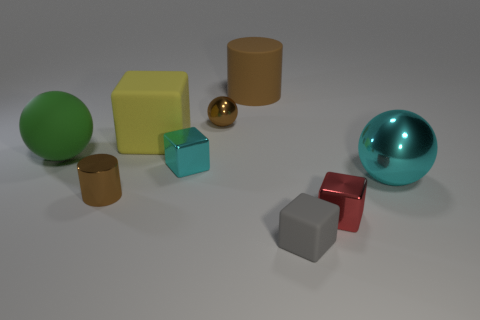There is a matte thing that is the same shape as the big metal thing; what is its size?
Ensure brevity in your answer.  Large. What number of purple things are shiny objects or large metal objects?
Keep it short and to the point. 0. How many small brown objects are right of the rubber cube that is behind the small gray cube?
Offer a terse response. 1. How many other objects are the same shape as the yellow thing?
Ensure brevity in your answer.  3. There is another object that is the same color as the big metal object; what is it made of?
Your answer should be very brief. Metal. What number of small shiny cylinders are the same color as the small matte object?
Ensure brevity in your answer.  0. There is a small cylinder that is the same material as the small ball; what color is it?
Offer a very short reply. Brown. Are there any cyan things of the same size as the yellow rubber cube?
Offer a terse response. Yes. Are there more brown objects that are in front of the tiny brown cylinder than green rubber balls behind the big green sphere?
Ensure brevity in your answer.  No. Do the large thing that is to the left of the big yellow block and the cylinder that is in front of the brown rubber thing have the same material?
Give a very brief answer. No. 